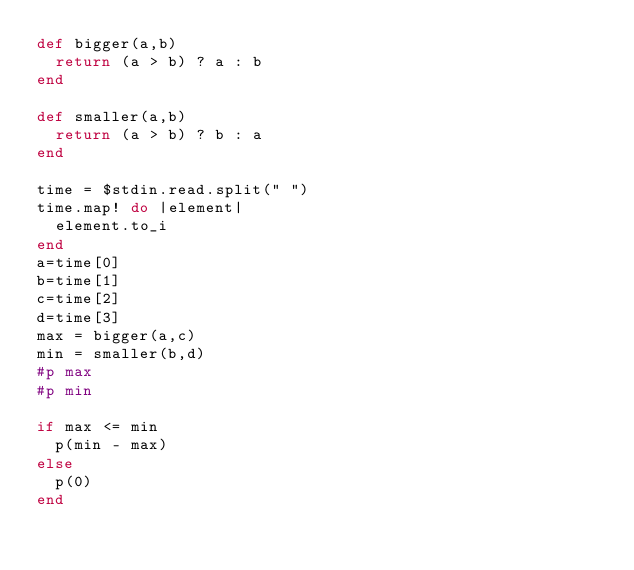Convert code to text. <code><loc_0><loc_0><loc_500><loc_500><_Ruby_>def bigger(a,b)
	return (a > b) ? a : b
end

def smaller(a,b)
	return (a > b) ? b : a
end

time = $stdin.read.split(" ")
time.map! do |element|
	element.to_i
end
a=time[0]
b=time[1]
c=time[2]
d=time[3]
max = bigger(a,c)
min = smaller(b,d)
#p max
#p min

if max <= min
	p(min - max)
else
	p(0)
end

</code> 